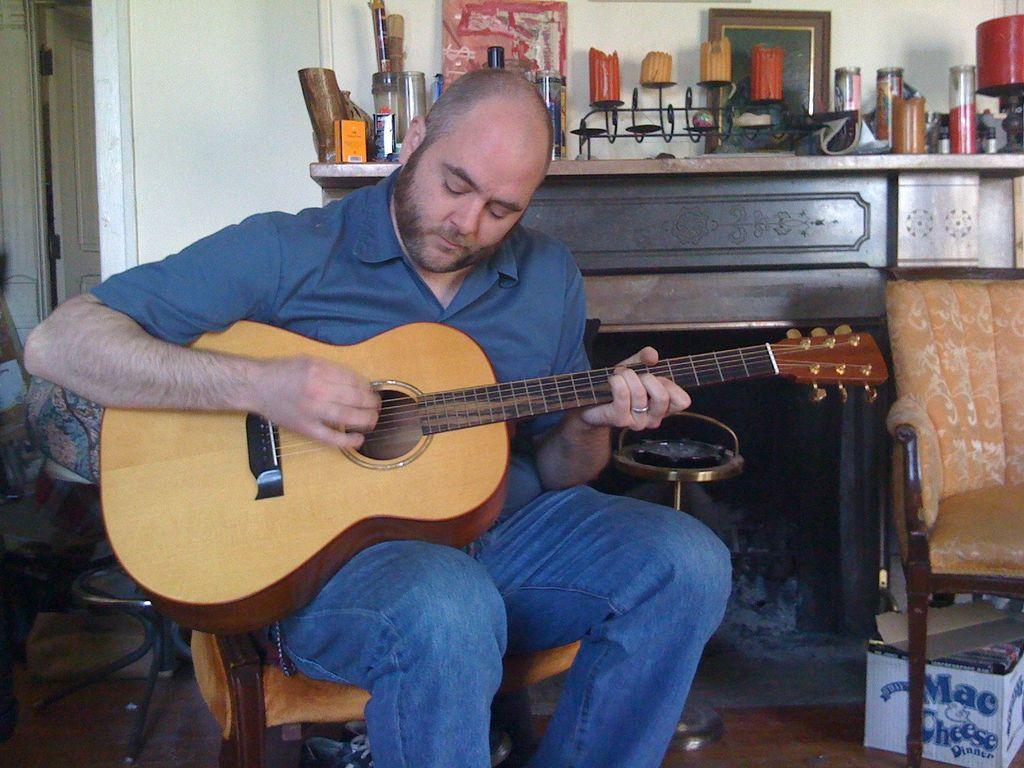Could you give a brief overview of what you see in this image? In this image there is a man sitting in chair and playing a guitar , and at back ground there is box, chair, fireplace , coal , candles, stand, frames attached to wall, glasses, box in a table , door. 